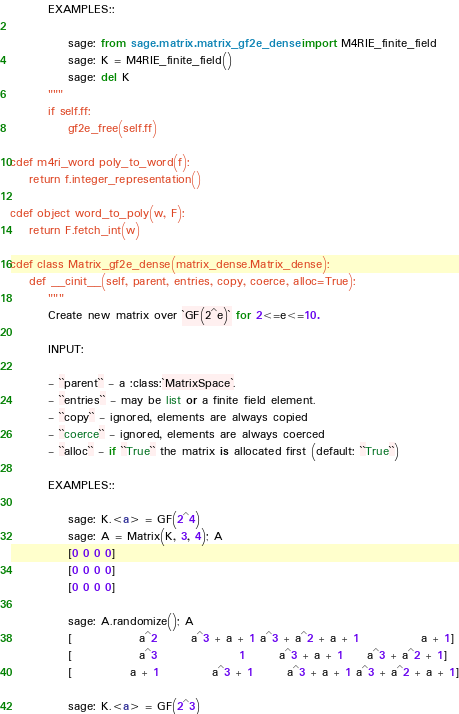Convert code to text. <code><loc_0><loc_0><loc_500><loc_500><_Cython_>        EXAMPLES::

            sage: from sage.matrix.matrix_gf2e_dense import M4RIE_finite_field
            sage: K = M4RIE_finite_field()
            sage: del K
        """
        if self.ff:
            gf2e_free(self.ff)

cdef m4ri_word poly_to_word(f):
    return f.integer_representation()

cdef object word_to_poly(w, F):
    return F.fetch_int(w)

cdef class Matrix_gf2e_dense(matrix_dense.Matrix_dense):
    def __cinit__(self, parent, entries, copy, coerce, alloc=True):
        """
        Create new matrix over `GF(2^e)` for 2<=e<=10.

        INPUT:

        - ``parent`` - a :class:`MatrixSpace`.
        - ``entries`` - may be list or a finite field element.
        - ``copy`` - ignored, elements are always copied
        - ``coerce`` - ignored, elements are always coerced
        - ``alloc`` - if ``True`` the matrix is allocated first (default: ``True``)

        EXAMPLES::

            sage: K.<a> = GF(2^4)
            sage: A = Matrix(K, 3, 4); A
            [0 0 0 0]
            [0 0 0 0]
            [0 0 0 0]

            sage: A.randomize(); A
            [              a^2       a^3 + a + 1 a^3 + a^2 + a + 1             a + 1]
            [              a^3                 1       a^3 + a + 1     a^3 + a^2 + 1]
            [            a + 1           a^3 + 1       a^3 + a + 1 a^3 + a^2 + a + 1]

            sage: K.<a> = GF(2^3)</code> 